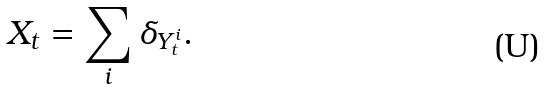Convert formula to latex. <formula><loc_0><loc_0><loc_500><loc_500>X _ { t } = \sum _ { i } \delta _ { Y ^ { i } _ { t } } .</formula> 